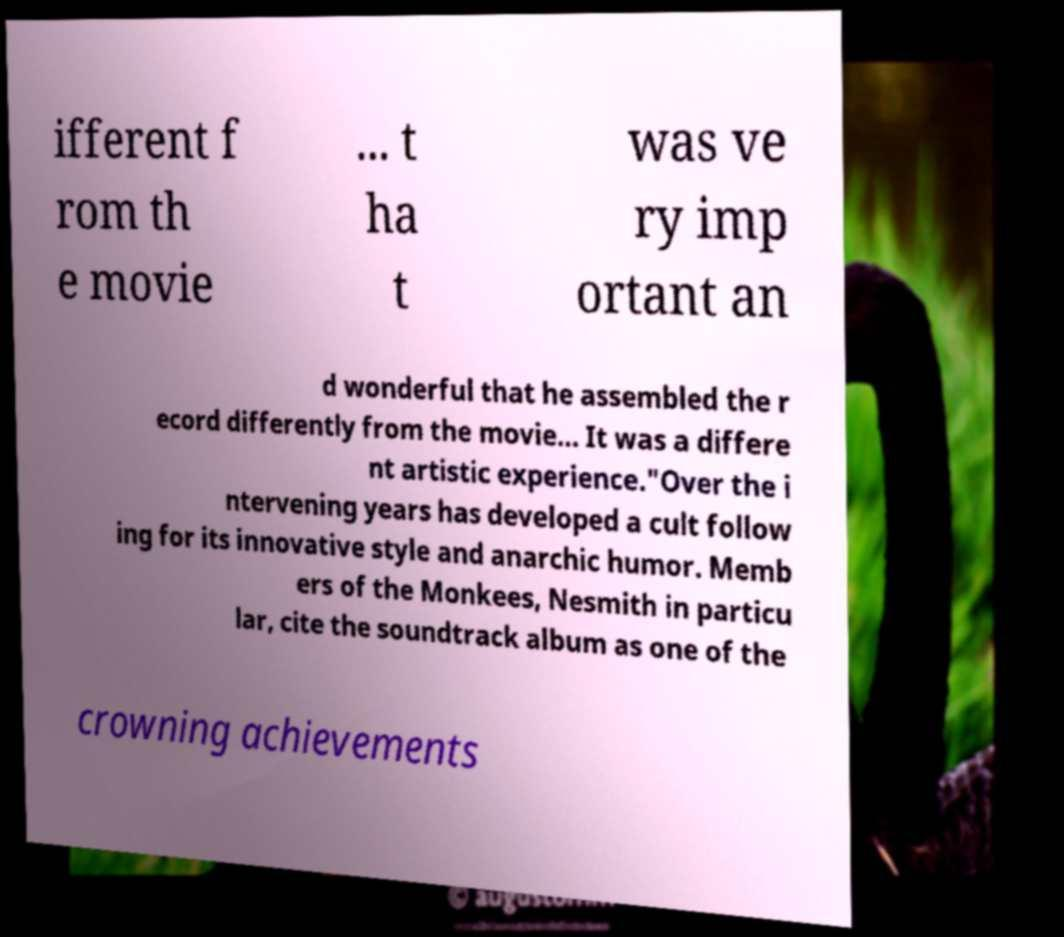Please read and relay the text visible in this image. What does it say? ifferent f rom th e movie ... t ha t was ve ry imp ortant an d wonderful that he assembled the r ecord differently from the movie... It was a differe nt artistic experience."Over the i ntervening years has developed a cult follow ing for its innovative style and anarchic humor. Memb ers of the Monkees, Nesmith in particu lar, cite the soundtrack album as one of the crowning achievements 